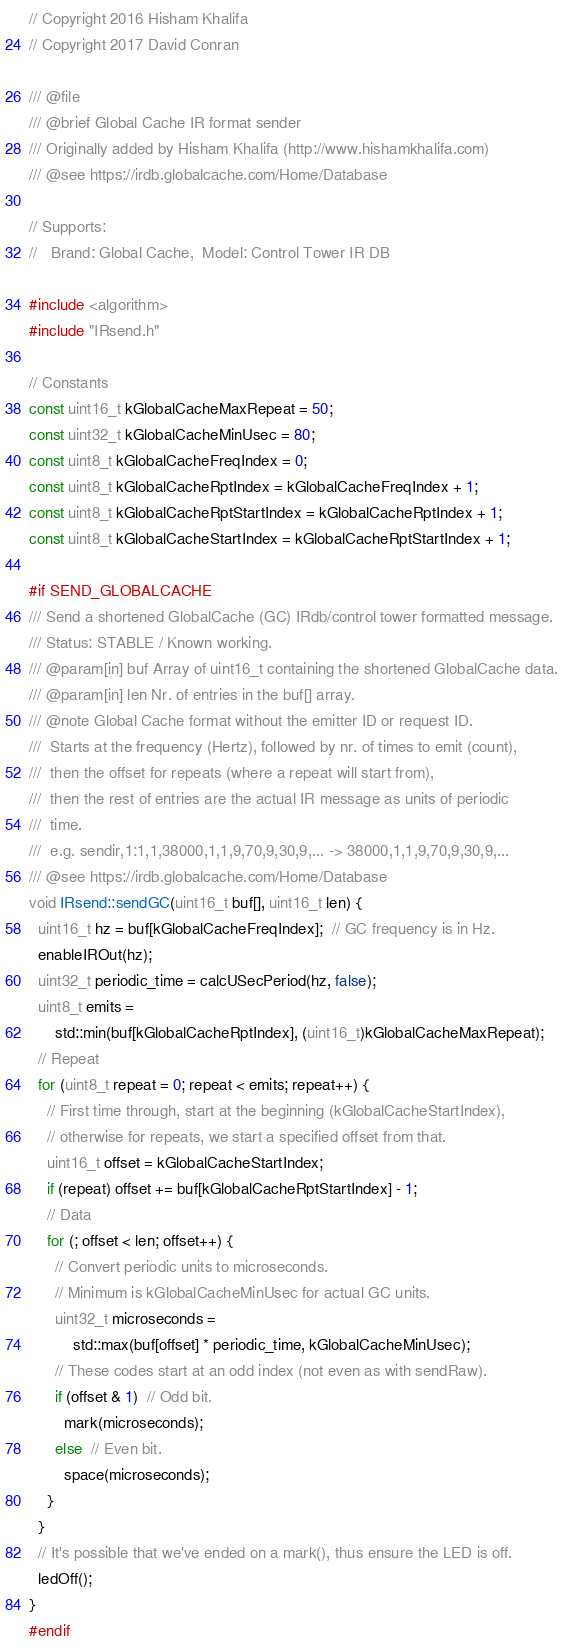<code> <loc_0><loc_0><loc_500><loc_500><_C++_>// Copyright 2016 Hisham Khalifa
// Copyright 2017 David Conran

/// @file
/// @brief Global Cache IR format sender
/// Originally added by Hisham Khalifa (http://www.hishamkhalifa.com)
/// @see https://irdb.globalcache.com/Home/Database

// Supports:
//   Brand: Global Cache,  Model: Control Tower IR DB

#include <algorithm>
#include "IRsend.h"

// Constants
const uint16_t kGlobalCacheMaxRepeat = 50;
const uint32_t kGlobalCacheMinUsec = 80;
const uint8_t kGlobalCacheFreqIndex = 0;
const uint8_t kGlobalCacheRptIndex = kGlobalCacheFreqIndex + 1;
const uint8_t kGlobalCacheRptStartIndex = kGlobalCacheRptIndex + 1;
const uint8_t kGlobalCacheStartIndex = kGlobalCacheRptStartIndex + 1;

#if SEND_GLOBALCACHE
/// Send a shortened GlobalCache (GC) IRdb/control tower formatted message.
/// Status: STABLE / Known working.
/// @param[in] buf Array of uint16_t containing the shortened GlobalCache data.
/// @param[in] len Nr. of entries in the buf[] array.
/// @note Global Cache format without the emitter ID or request ID.
///  Starts at the frequency (Hertz), followed by nr. of times to emit (count),
///  then the offset for repeats (where a repeat will start from),
///  then the rest of entries are the actual IR message as units of periodic
///  time.
///  e.g. sendir,1:1,1,38000,1,1,9,70,9,30,9,... -> 38000,1,1,9,70,9,30,9,...
/// @see https://irdb.globalcache.com/Home/Database
void IRsend::sendGC(uint16_t buf[], uint16_t len) {
  uint16_t hz = buf[kGlobalCacheFreqIndex];  // GC frequency is in Hz.
  enableIROut(hz);
  uint32_t periodic_time = calcUSecPeriod(hz, false);
  uint8_t emits =
      std::min(buf[kGlobalCacheRptIndex], (uint16_t)kGlobalCacheMaxRepeat);
  // Repeat
  for (uint8_t repeat = 0; repeat < emits; repeat++) {
    // First time through, start at the beginning (kGlobalCacheStartIndex),
    // otherwise for repeats, we start a specified offset from that.
    uint16_t offset = kGlobalCacheStartIndex;
    if (repeat) offset += buf[kGlobalCacheRptStartIndex] - 1;
    // Data
    for (; offset < len; offset++) {
      // Convert periodic units to microseconds.
      // Minimum is kGlobalCacheMinUsec for actual GC units.
      uint32_t microseconds =
          std::max(buf[offset] * periodic_time, kGlobalCacheMinUsec);
      // These codes start at an odd index (not even as with sendRaw).
      if (offset & 1)  // Odd bit.
        mark(microseconds);
      else  // Even bit.
        space(microseconds);
    }
  }
  // It's possible that we've ended on a mark(), thus ensure the LED is off.
  ledOff();
}
#endif
</code> 